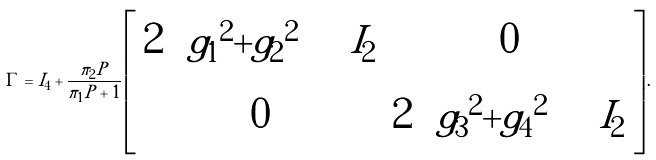<formula> <loc_0><loc_0><loc_500><loc_500>\Gamma = I _ { 4 } + \frac { \pi _ { 2 } P } { \pi _ { 1 } P + 1 } \left [ \begin{array} { c c } 2 \left ( | g _ { 1 } | ^ { 2 } + | g _ { 2 } | ^ { 2 } \right ) I _ { 2 } & 0 \\ 0 & 2 \left ( | g _ { 3 } | ^ { 2 } + | g _ { 4 } | ^ { 2 } \right ) I _ { 2 } \end{array} \right ] .</formula> 